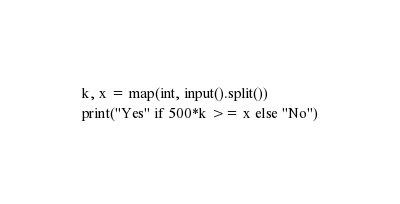Convert code to text. <code><loc_0><loc_0><loc_500><loc_500><_Python_>k, x = map(int, input().split())
print("Yes" if 500*k >= x else "No")</code> 